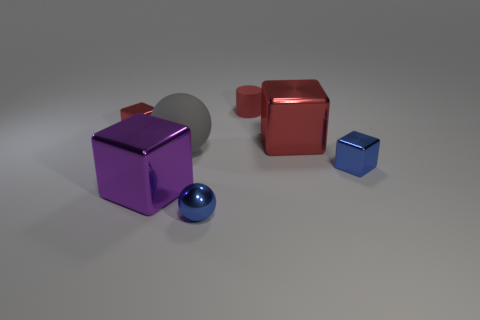What might be the purpose of arranging these objects in this way? This arrangement of objects could serve several purposes. It resembles a still life composition, often used in photography or art to study shapes, colors, and textures. It could also be a visual exercise, perhaps for a 3D modeling showcase or a physics demonstration of materials and reflections. The contrasting colors and shapes encourage viewers to compare and contrast the visual elements. 